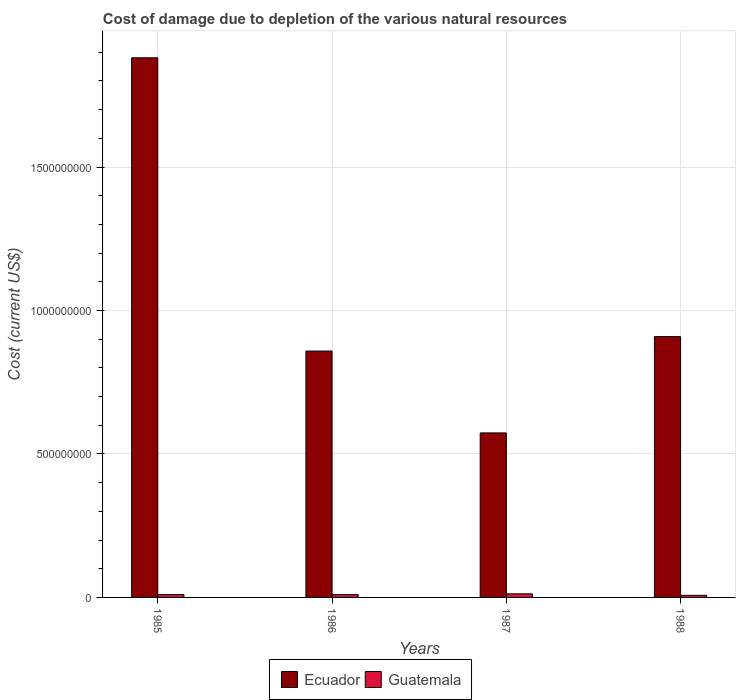How many different coloured bars are there?
Keep it short and to the point. 2. How many groups of bars are there?
Your answer should be very brief. 4. How many bars are there on the 1st tick from the left?
Offer a very short reply. 2. How many bars are there on the 1st tick from the right?
Make the answer very short. 2. What is the label of the 2nd group of bars from the left?
Offer a very short reply. 1986. In how many cases, is the number of bars for a given year not equal to the number of legend labels?
Offer a very short reply. 0. What is the cost of damage caused due to the depletion of various natural resources in Ecuador in 1985?
Provide a succinct answer. 1.88e+09. Across all years, what is the maximum cost of damage caused due to the depletion of various natural resources in Ecuador?
Ensure brevity in your answer.  1.88e+09. Across all years, what is the minimum cost of damage caused due to the depletion of various natural resources in Ecuador?
Offer a very short reply. 5.73e+08. In which year was the cost of damage caused due to the depletion of various natural resources in Guatemala minimum?
Make the answer very short. 1988. What is the total cost of damage caused due to the depletion of various natural resources in Ecuador in the graph?
Offer a very short reply. 4.22e+09. What is the difference between the cost of damage caused due to the depletion of various natural resources in Guatemala in 1985 and that in 1988?
Your response must be concise. 2.49e+06. What is the difference between the cost of damage caused due to the depletion of various natural resources in Ecuador in 1988 and the cost of damage caused due to the depletion of various natural resources in Guatemala in 1985?
Provide a succinct answer. 8.99e+08. What is the average cost of damage caused due to the depletion of various natural resources in Ecuador per year?
Your answer should be very brief. 1.06e+09. In the year 1985, what is the difference between the cost of damage caused due to the depletion of various natural resources in Guatemala and cost of damage caused due to the depletion of various natural resources in Ecuador?
Ensure brevity in your answer.  -1.87e+09. What is the ratio of the cost of damage caused due to the depletion of various natural resources in Ecuador in 1985 to that in 1987?
Your answer should be very brief. 3.28. Is the difference between the cost of damage caused due to the depletion of various natural resources in Guatemala in 1986 and 1987 greater than the difference between the cost of damage caused due to the depletion of various natural resources in Ecuador in 1986 and 1987?
Your answer should be compact. No. What is the difference between the highest and the second highest cost of damage caused due to the depletion of various natural resources in Ecuador?
Offer a terse response. 9.72e+08. What is the difference between the highest and the lowest cost of damage caused due to the depletion of various natural resources in Ecuador?
Your response must be concise. 1.31e+09. In how many years, is the cost of damage caused due to the depletion of various natural resources in Ecuador greater than the average cost of damage caused due to the depletion of various natural resources in Ecuador taken over all years?
Give a very brief answer. 1. What does the 2nd bar from the left in 1988 represents?
Provide a short and direct response. Guatemala. What does the 1st bar from the right in 1987 represents?
Offer a very short reply. Guatemala. How many bars are there?
Provide a short and direct response. 8. Does the graph contain any zero values?
Ensure brevity in your answer.  No. How many legend labels are there?
Ensure brevity in your answer.  2. What is the title of the graph?
Your response must be concise. Cost of damage due to depletion of the various natural resources. What is the label or title of the X-axis?
Your answer should be very brief. Years. What is the label or title of the Y-axis?
Your answer should be very brief. Cost (current US$). What is the Cost (current US$) in Ecuador in 1985?
Provide a succinct answer. 1.88e+09. What is the Cost (current US$) of Guatemala in 1985?
Your answer should be compact. 9.85e+06. What is the Cost (current US$) in Ecuador in 1986?
Your answer should be very brief. 8.59e+08. What is the Cost (current US$) in Guatemala in 1986?
Provide a short and direct response. 9.75e+06. What is the Cost (current US$) in Ecuador in 1987?
Give a very brief answer. 5.73e+08. What is the Cost (current US$) in Guatemala in 1987?
Provide a succinct answer. 1.25e+07. What is the Cost (current US$) of Ecuador in 1988?
Ensure brevity in your answer.  9.09e+08. What is the Cost (current US$) of Guatemala in 1988?
Provide a succinct answer. 7.36e+06. Across all years, what is the maximum Cost (current US$) in Ecuador?
Provide a succinct answer. 1.88e+09. Across all years, what is the maximum Cost (current US$) in Guatemala?
Provide a succinct answer. 1.25e+07. Across all years, what is the minimum Cost (current US$) of Ecuador?
Your answer should be very brief. 5.73e+08. Across all years, what is the minimum Cost (current US$) of Guatemala?
Give a very brief answer. 7.36e+06. What is the total Cost (current US$) of Ecuador in the graph?
Your answer should be compact. 4.22e+09. What is the total Cost (current US$) of Guatemala in the graph?
Make the answer very short. 3.94e+07. What is the difference between the Cost (current US$) of Ecuador in 1985 and that in 1986?
Provide a succinct answer. 1.02e+09. What is the difference between the Cost (current US$) of Guatemala in 1985 and that in 1986?
Give a very brief answer. 1.01e+05. What is the difference between the Cost (current US$) of Ecuador in 1985 and that in 1987?
Your answer should be compact. 1.31e+09. What is the difference between the Cost (current US$) of Guatemala in 1985 and that in 1987?
Your answer should be very brief. -2.62e+06. What is the difference between the Cost (current US$) in Ecuador in 1985 and that in 1988?
Provide a short and direct response. 9.72e+08. What is the difference between the Cost (current US$) in Guatemala in 1985 and that in 1988?
Your response must be concise. 2.49e+06. What is the difference between the Cost (current US$) of Ecuador in 1986 and that in 1987?
Ensure brevity in your answer.  2.85e+08. What is the difference between the Cost (current US$) of Guatemala in 1986 and that in 1987?
Make the answer very short. -2.72e+06. What is the difference between the Cost (current US$) of Ecuador in 1986 and that in 1988?
Keep it short and to the point. -5.03e+07. What is the difference between the Cost (current US$) in Guatemala in 1986 and that in 1988?
Your answer should be compact. 2.39e+06. What is the difference between the Cost (current US$) in Ecuador in 1987 and that in 1988?
Provide a short and direct response. -3.36e+08. What is the difference between the Cost (current US$) of Guatemala in 1987 and that in 1988?
Provide a short and direct response. 5.11e+06. What is the difference between the Cost (current US$) of Ecuador in 1985 and the Cost (current US$) of Guatemala in 1986?
Offer a terse response. 1.87e+09. What is the difference between the Cost (current US$) of Ecuador in 1985 and the Cost (current US$) of Guatemala in 1987?
Give a very brief answer. 1.87e+09. What is the difference between the Cost (current US$) of Ecuador in 1985 and the Cost (current US$) of Guatemala in 1988?
Offer a very short reply. 1.87e+09. What is the difference between the Cost (current US$) of Ecuador in 1986 and the Cost (current US$) of Guatemala in 1987?
Your answer should be compact. 8.46e+08. What is the difference between the Cost (current US$) in Ecuador in 1986 and the Cost (current US$) in Guatemala in 1988?
Keep it short and to the point. 8.51e+08. What is the difference between the Cost (current US$) in Ecuador in 1987 and the Cost (current US$) in Guatemala in 1988?
Your answer should be very brief. 5.66e+08. What is the average Cost (current US$) in Ecuador per year?
Offer a very short reply. 1.06e+09. What is the average Cost (current US$) in Guatemala per year?
Offer a terse response. 9.85e+06. In the year 1985, what is the difference between the Cost (current US$) of Ecuador and Cost (current US$) of Guatemala?
Make the answer very short. 1.87e+09. In the year 1986, what is the difference between the Cost (current US$) in Ecuador and Cost (current US$) in Guatemala?
Ensure brevity in your answer.  8.49e+08. In the year 1987, what is the difference between the Cost (current US$) of Ecuador and Cost (current US$) of Guatemala?
Provide a short and direct response. 5.61e+08. In the year 1988, what is the difference between the Cost (current US$) of Ecuador and Cost (current US$) of Guatemala?
Keep it short and to the point. 9.02e+08. What is the ratio of the Cost (current US$) of Ecuador in 1985 to that in 1986?
Your answer should be compact. 2.19. What is the ratio of the Cost (current US$) of Guatemala in 1985 to that in 1986?
Your response must be concise. 1.01. What is the ratio of the Cost (current US$) of Ecuador in 1985 to that in 1987?
Provide a short and direct response. 3.28. What is the ratio of the Cost (current US$) in Guatemala in 1985 to that in 1987?
Your answer should be compact. 0.79. What is the ratio of the Cost (current US$) of Ecuador in 1985 to that in 1988?
Keep it short and to the point. 2.07. What is the ratio of the Cost (current US$) of Guatemala in 1985 to that in 1988?
Offer a very short reply. 1.34. What is the ratio of the Cost (current US$) of Ecuador in 1986 to that in 1987?
Provide a succinct answer. 1.5. What is the ratio of the Cost (current US$) in Guatemala in 1986 to that in 1987?
Offer a very short reply. 0.78. What is the ratio of the Cost (current US$) of Ecuador in 1986 to that in 1988?
Provide a succinct answer. 0.94. What is the ratio of the Cost (current US$) in Guatemala in 1986 to that in 1988?
Offer a very short reply. 1.32. What is the ratio of the Cost (current US$) in Ecuador in 1987 to that in 1988?
Provide a short and direct response. 0.63. What is the ratio of the Cost (current US$) in Guatemala in 1987 to that in 1988?
Your answer should be compact. 1.69. What is the difference between the highest and the second highest Cost (current US$) of Ecuador?
Make the answer very short. 9.72e+08. What is the difference between the highest and the second highest Cost (current US$) of Guatemala?
Your response must be concise. 2.62e+06. What is the difference between the highest and the lowest Cost (current US$) in Ecuador?
Give a very brief answer. 1.31e+09. What is the difference between the highest and the lowest Cost (current US$) in Guatemala?
Keep it short and to the point. 5.11e+06. 